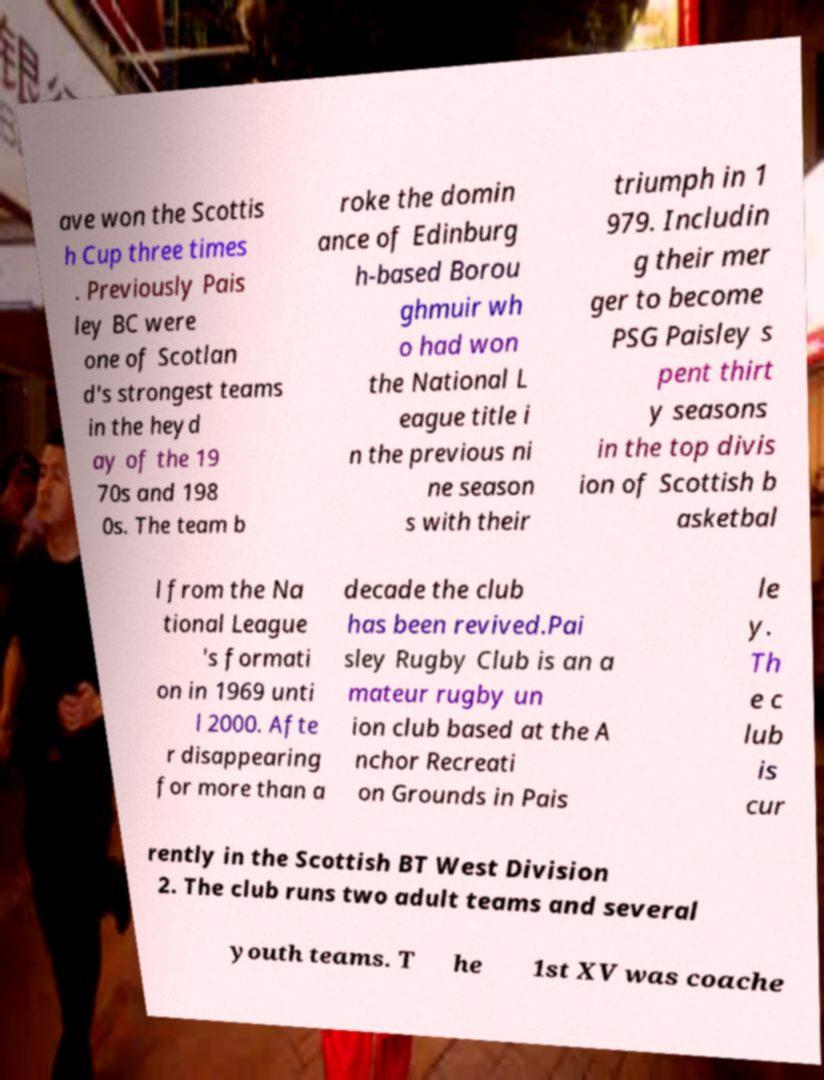For documentation purposes, I need the text within this image transcribed. Could you provide that? ave won the Scottis h Cup three times . Previously Pais ley BC were one of Scotlan d's strongest teams in the heyd ay of the 19 70s and 198 0s. The team b roke the domin ance of Edinburg h-based Borou ghmuir wh o had won the National L eague title i n the previous ni ne season s with their triumph in 1 979. Includin g their mer ger to become PSG Paisley s pent thirt y seasons in the top divis ion of Scottish b asketbal l from the Na tional League 's formati on in 1969 unti l 2000. Afte r disappearing for more than a decade the club has been revived.Pai sley Rugby Club is an a mateur rugby un ion club based at the A nchor Recreati on Grounds in Pais le y. Th e c lub is cur rently in the Scottish BT West Division 2. The club runs two adult teams and several youth teams. T he 1st XV was coache 